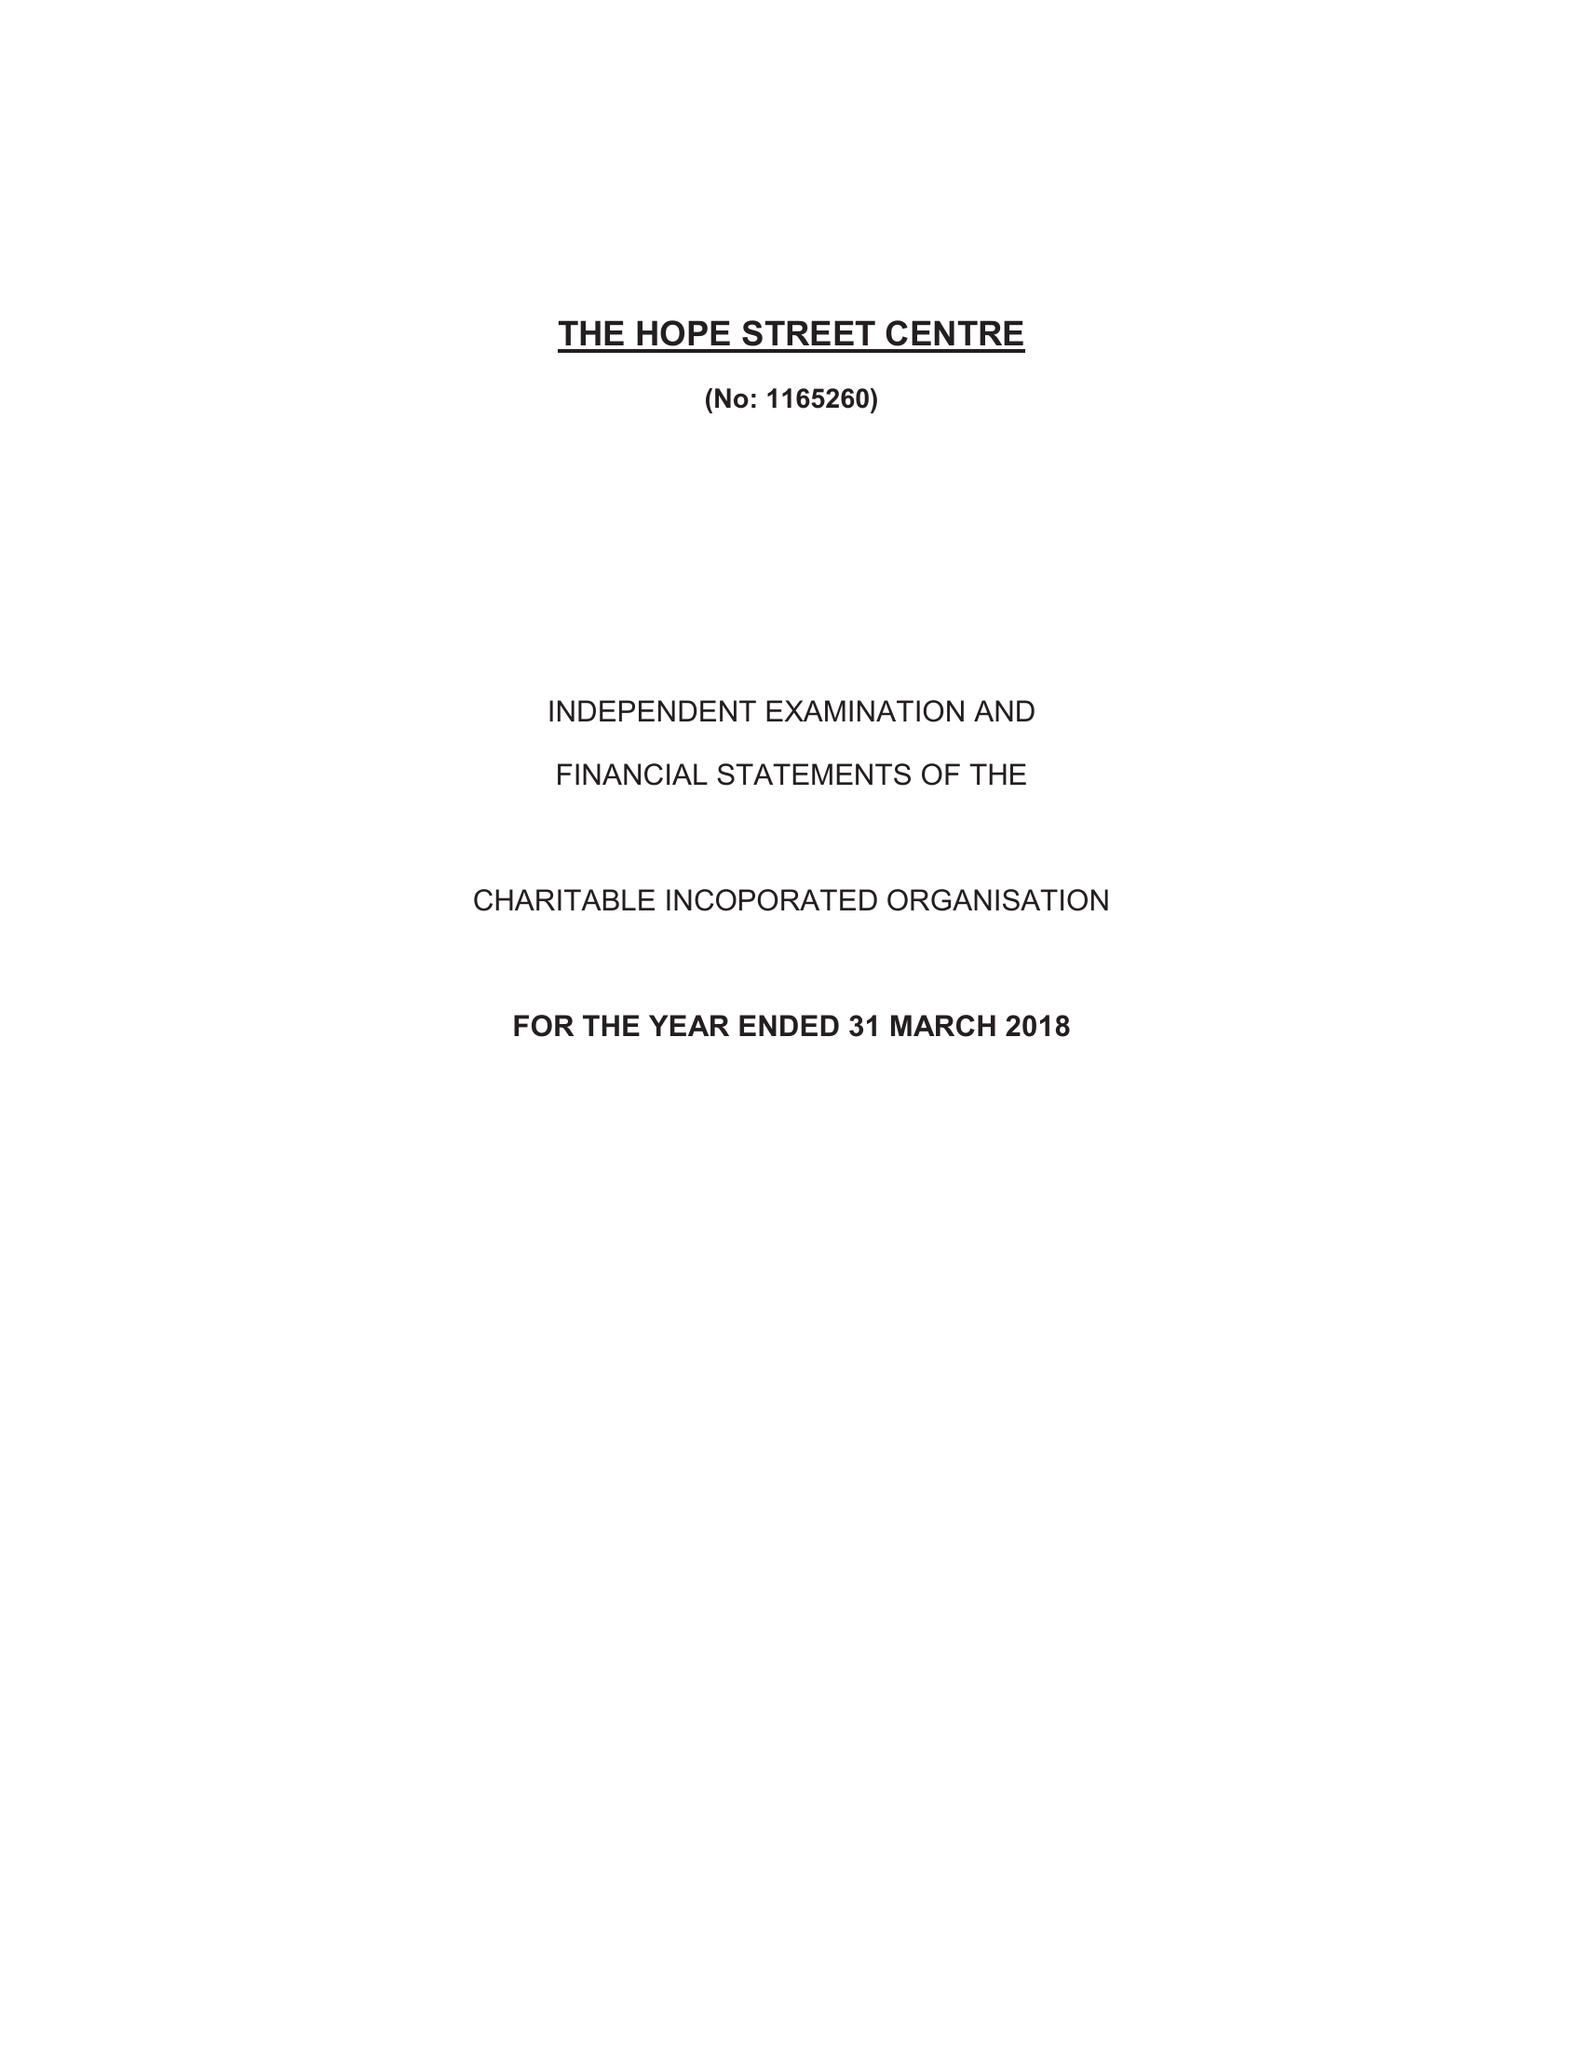What is the value for the charity_name?
Answer the question using a single word or phrase. The Hope Street Centre 